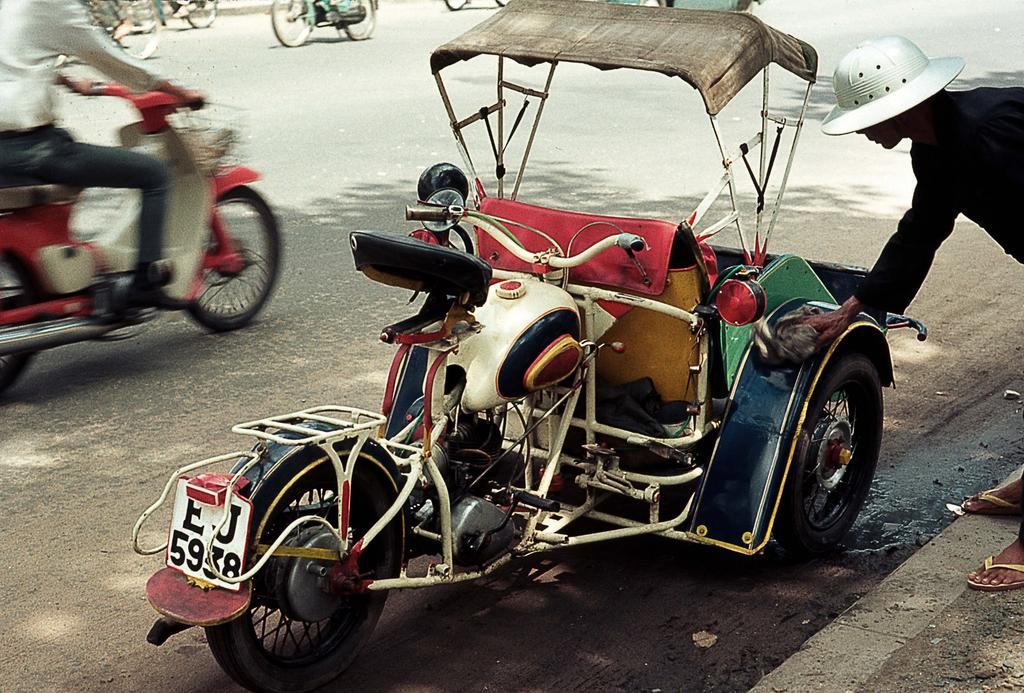What is the main subject of the picture? The main subject of the picture is a motorbike. What is the person in the image doing? The person is cleaning the motorbike. Are there any other motorcycles visible in the image? Yes, there are other motorcycles visible on the road. What type of light is being used by the girl to clean the motorbike in the image? There is no girl present in the image, and no light source is mentioned or visible in the image. 